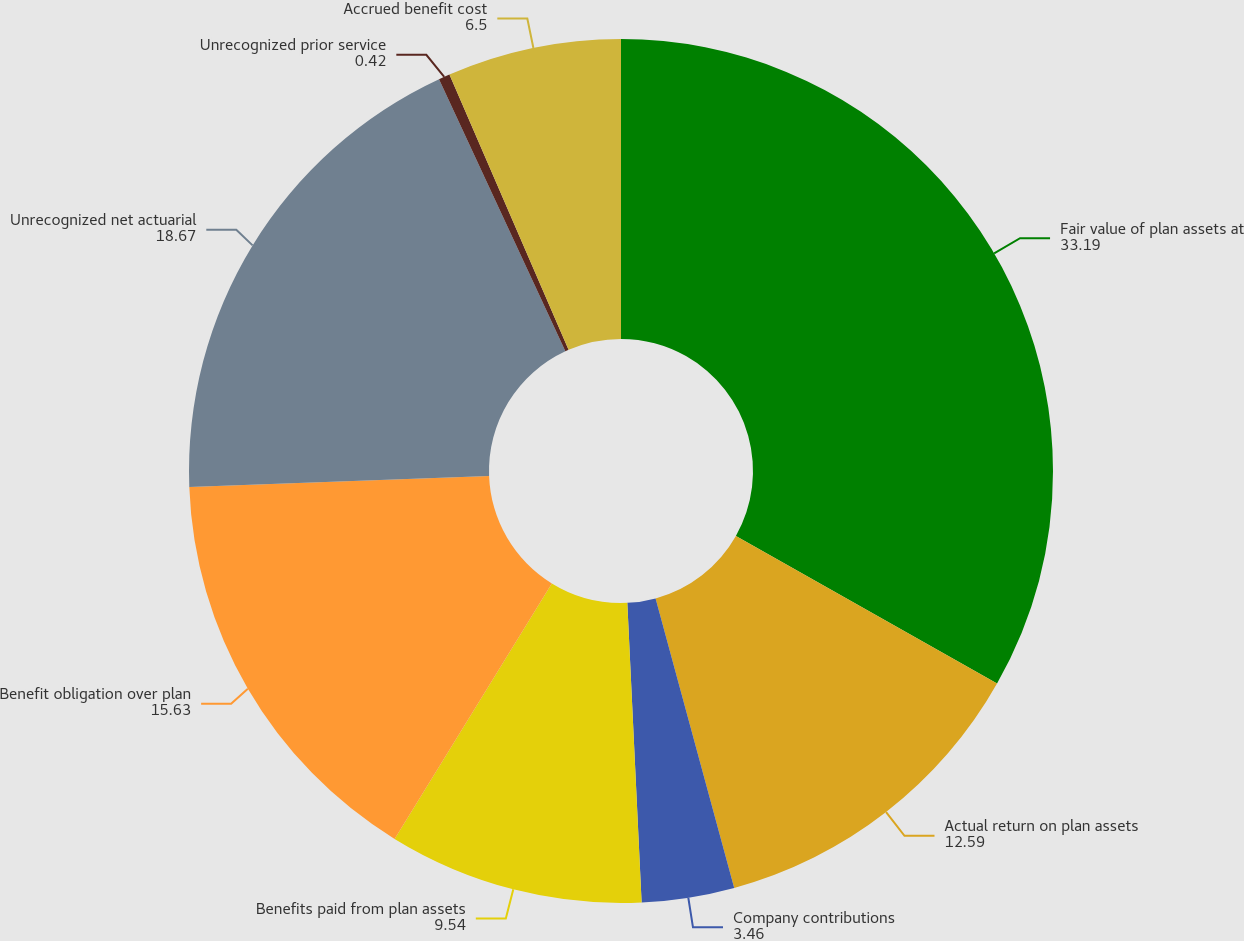<chart> <loc_0><loc_0><loc_500><loc_500><pie_chart><fcel>Fair value of plan assets at<fcel>Actual return on plan assets<fcel>Company contributions<fcel>Benefits paid from plan assets<fcel>Benefit obligation over plan<fcel>Unrecognized net actuarial<fcel>Unrecognized prior service<fcel>Accrued benefit cost<nl><fcel>33.19%<fcel>12.59%<fcel>3.46%<fcel>9.54%<fcel>15.63%<fcel>18.67%<fcel>0.42%<fcel>6.5%<nl></chart> 